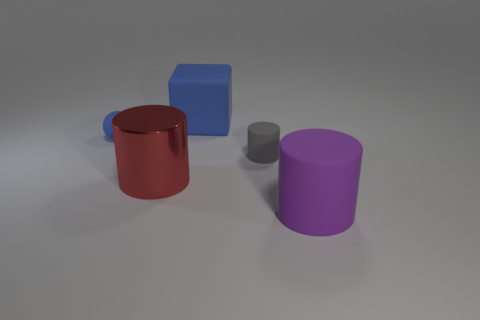Add 3 large red metallic things. How many objects exist? 8 Subtract all big gray shiny objects. Subtract all small blue spheres. How many objects are left? 4 Add 5 big red metallic cylinders. How many big red metallic cylinders are left? 6 Add 1 blue matte balls. How many blue matte balls exist? 2 Subtract all red cylinders. How many cylinders are left? 2 Subtract all tiny gray matte cylinders. How many cylinders are left? 2 Subtract 0 cyan cylinders. How many objects are left? 5 Subtract all cylinders. How many objects are left? 2 Subtract 1 balls. How many balls are left? 0 Subtract all yellow cylinders. Subtract all red blocks. How many cylinders are left? 3 